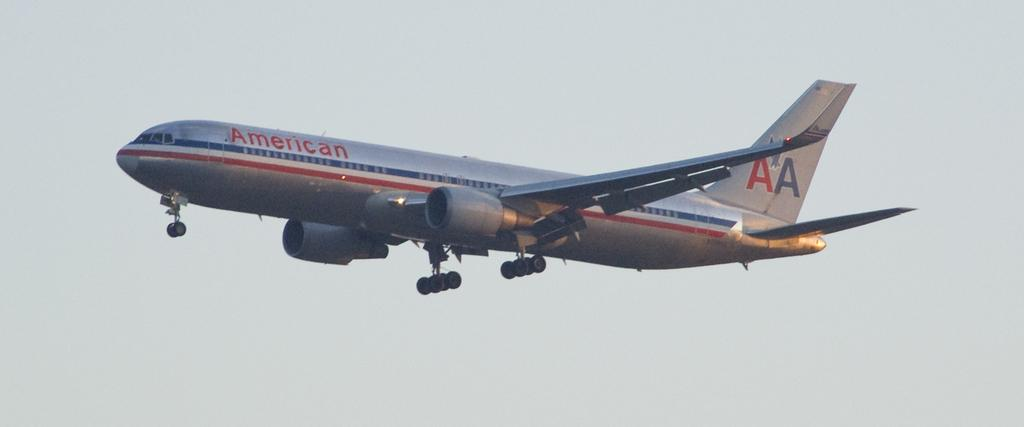What is the main subject of the picture? The main subject of the picture is an airplane. Can you describe the position of the airplane in the image? The airplane is in the air. What type of mine can be seen in the image? There is no mine present in the image; it features an airplane in the air. What attraction is visible in the image? There is no attraction visible in the image; it only shows an airplane in the air. 